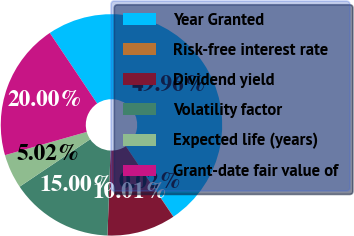Convert chart. <chart><loc_0><loc_0><loc_500><loc_500><pie_chart><fcel>Year Granted<fcel>Risk-free interest rate<fcel>Dividend yield<fcel>Volatility factor<fcel>Expected life (years)<fcel>Grant-date fair value of<nl><fcel>49.96%<fcel>0.02%<fcel>10.01%<fcel>15.0%<fcel>5.02%<fcel>20.0%<nl></chart> 